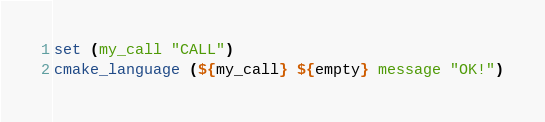Convert code to text. <code><loc_0><loc_0><loc_500><loc_500><_CMake_>set (my_call "CALL")
cmake_language (${my_call} ${empty} message "OK!")
</code> 